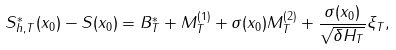<formula> <loc_0><loc_0><loc_500><loc_500>S ^ { * } _ { h , T } ( x _ { 0 } ) - S ( x _ { 0 } ) = B ^ { * } _ { T } + M ^ { ( 1 ) } _ { T } + \sigma ( x _ { 0 } ) M ^ { ( 2 ) } _ { T } + \frac { \sigma ( x _ { 0 } ) } { \sqrt { \delta H _ { T } } } \xi _ { T } ,</formula> 